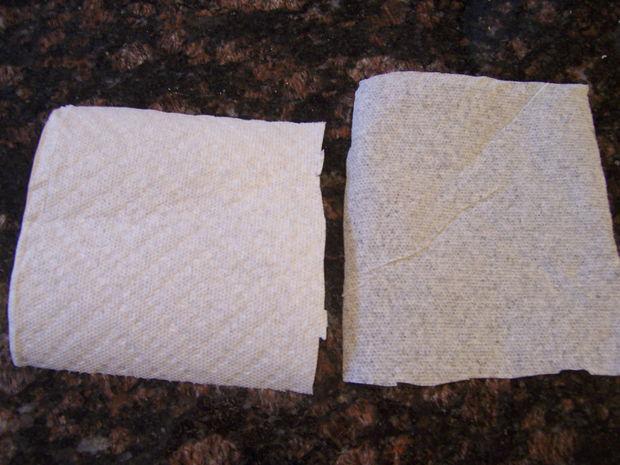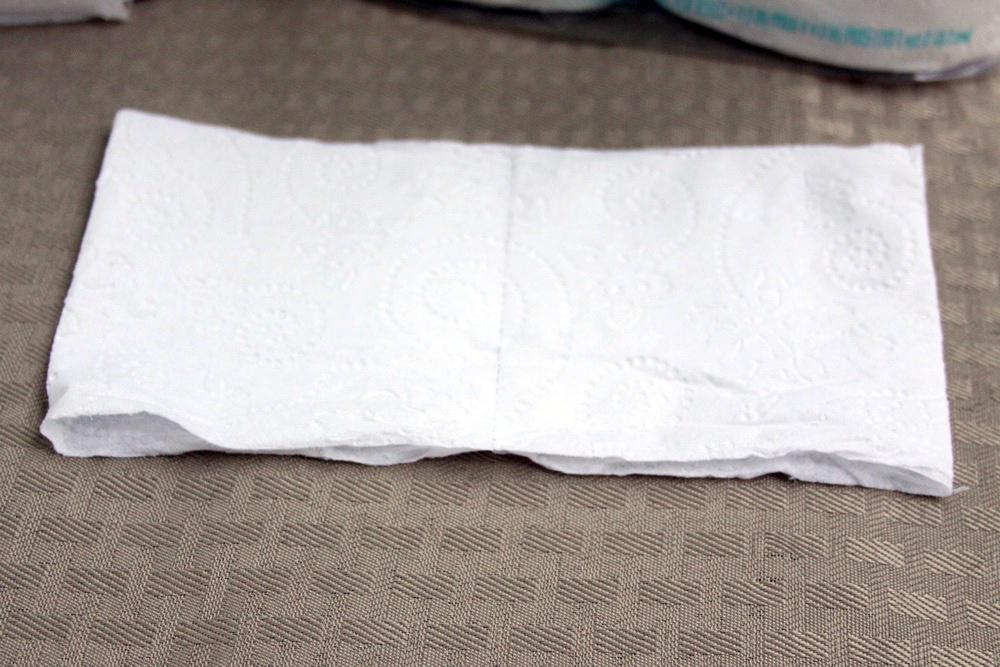The first image is the image on the left, the second image is the image on the right. For the images displayed, is the sentence "There are exactly five visible paper towels." factually correct? Answer yes or no. No. The first image is the image on the left, the second image is the image on the right. For the images shown, is this caption "An image shows overlapping square white paper towels, each with the same embossed pattern." true? Answer yes or no. No. 